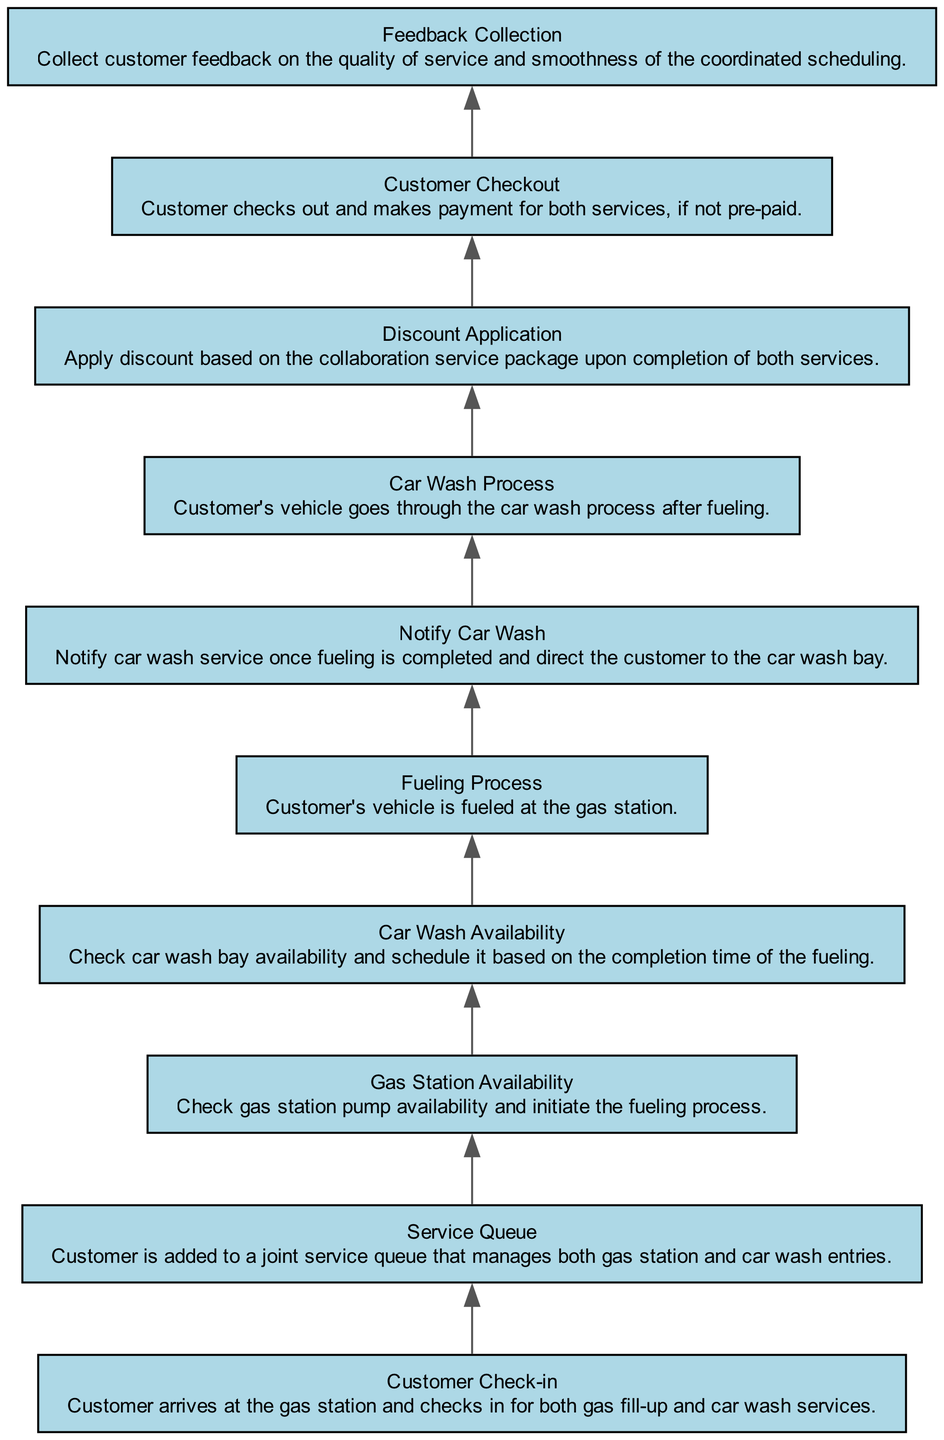What is the first step the customer takes? The diagram shows that the first step in the flow is "Customer Check-in," where the customer arrives and checks in for both gas fill-up and car wash services.
Answer: Customer Check-in How many elements are in the flowchart? By counting the components listed in the diagram, we can determine that there are ten elements from "Customer Check-in" to "Feedback Collection."
Answer: 10 What happens after the "Fueling Process"? Upon completing the "Fueling Process," the next step is to "Notify Car Wash," indicating that the process of informing the car wash service begins.
Answer: Notify Car Wash What is done during the "Customer Checkout"? The "Customer Checkout" step involves the customer checking out and making payment for both services, summarizing the final part of the service sequence.
Answer: Checkout and payment What must be available before the fueling can start? Before the fueling process can be initiated, the "Gas Station Availability" must be confirmed to ensure that there is an available pump for the customer.
Answer: Gas Station Availability What is the last step in the flowchart? The last step that concludes the flow is "Feedback Collection," where the customer provides feedback on their experience regarding the services received.
Answer: Feedback Collection What are the two services combined in this coordinated scheduling? The coordinated scheduling combines the services of the gas station and the car wash, integrating both processes into a single experience for the customer.
Answer: Gas station and car wash Which step follows the "Car Wash Process"? After completing the "Car Wash Process," the next action listed is to apply discounts based on the collaboration service package enjoyed by the customer.
Answer: Discount Application What is the primary purpose of the "Service Queue"? The "Service Queue" serves as a joint service management system that organizes and tracks customers waiting for both gas and car wash services, thus ensuring smooth operations.
Answer: Joint service queue management 